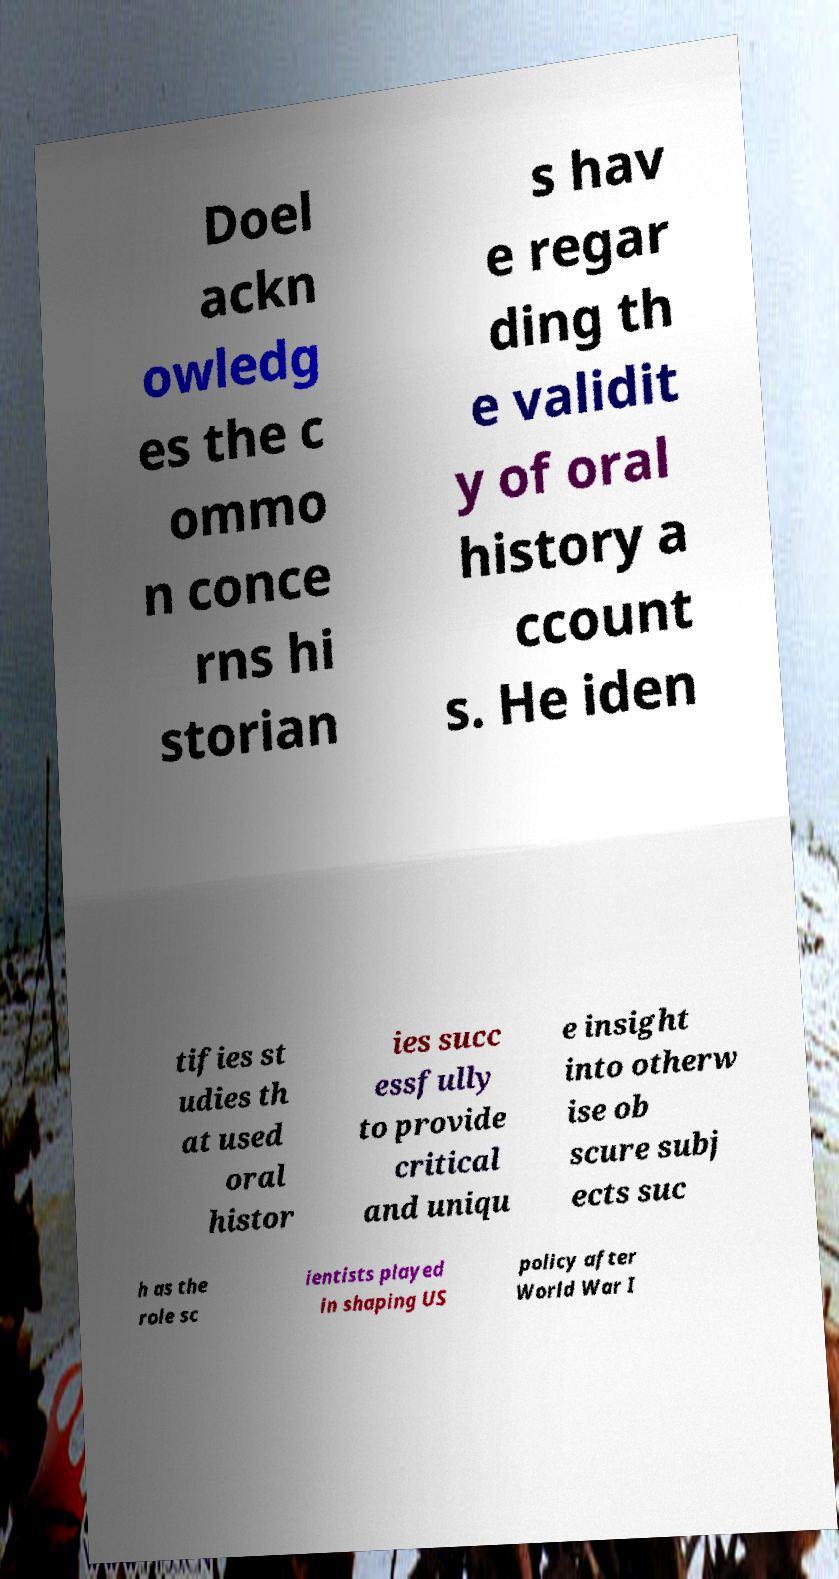There's text embedded in this image that I need extracted. Can you transcribe it verbatim? Doel ackn owledg es the c ommo n conce rns hi storian s hav e regar ding th e validit y of oral history a ccount s. He iden tifies st udies th at used oral histor ies succ essfully to provide critical and uniqu e insight into otherw ise ob scure subj ects suc h as the role sc ientists played in shaping US policy after World War I 